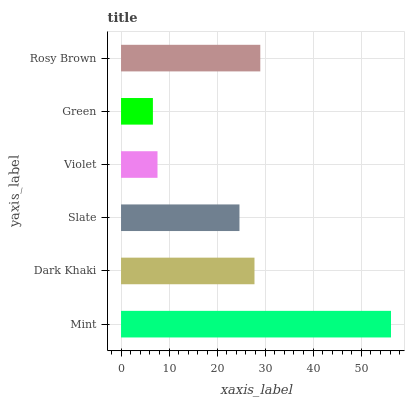Is Green the minimum?
Answer yes or no. Yes. Is Mint the maximum?
Answer yes or no. Yes. Is Dark Khaki the minimum?
Answer yes or no. No. Is Dark Khaki the maximum?
Answer yes or no. No. Is Mint greater than Dark Khaki?
Answer yes or no. Yes. Is Dark Khaki less than Mint?
Answer yes or no. Yes. Is Dark Khaki greater than Mint?
Answer yes or no. No. Is Mint less than Dark Khaki?
Answer yes or no. No. Is Dark Khaki the high median?
Answer yes or no. Yes. Is Slate the low median?
Answer yes or no. Yes. Is Violet the high median?
Answer yes or no. No. Is Green the low median?
Answer yes or no. No. 